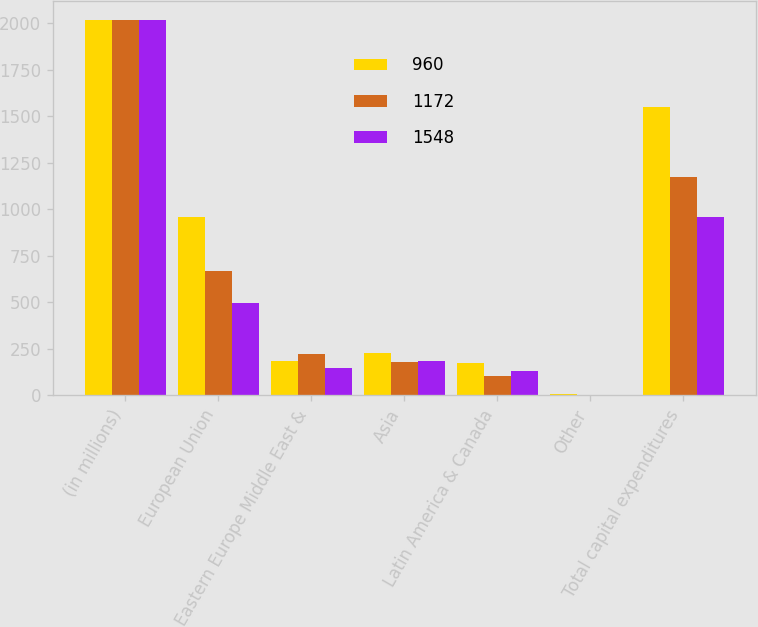Convert chart to OTSL. <chart><loc_0><loc_0><loc_500><loc_500><stacked_bar_chart><ecel><fcel>(in millions)<fcel>European Union<fcel>Eastern Europe Middle East &<fcel>Asia<fcel>Latin America & Canada<fcel>Other<fcel>Total capital expenditures<nl><fcel>960<fcel>2017<fcel>956<fcel>182<fcel>227<fcel>175<fcel>8<fcel>1548<nl><fcel>1172<fcel>2016<fcel>665<fcel>223<fcel>180<fcel>103<fcel>1<fcel>1172<nl><fcel>1548<fcel>2015<fcel>497<fcel>147<fcel>185<fcel>130<fcel>1<fcel>960<nl></chart> 